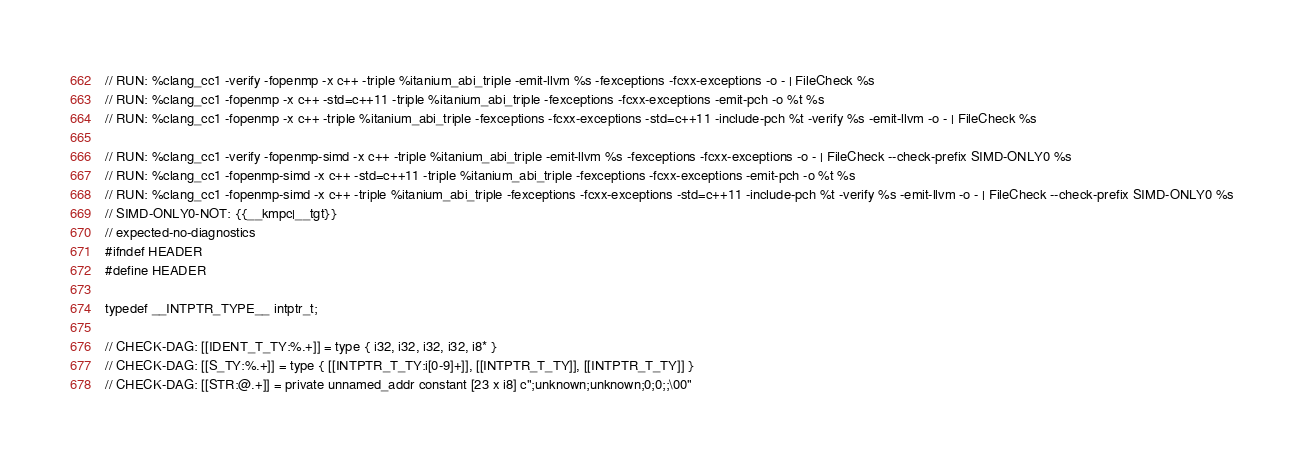Convert code to text. <code><loc_0><loc_0><loc_500><loc_500><_C++_>// RUN: %clang_cc1 -verify -fopenmp -x c++ -triple %itanium_abi_triple -emit-llvm %s -fexceptions -fcxx-exceptions -o - | FileCheck %s
// RUN: %clang_cc1 -fopenmp -x c++ -std=c++11 -triple %itanium_abi_triple -fexceptions -fcxx-exceptions -emit-pch -o %t %s
// RUN: %clang_cc1 -fopenmp -x c++ -triple %itanium_abi_triple -fexceptions -fcxx-exceptions -std=c++11 -include-pch %t -verify %s -emit-llvm -o - | FileCheck %s

// RUN: %clang_cc1 -verify -fopenmp-simd -x c++ -triple %itanium_abi_triple -emit-llvm %s -fexceptions -fcxx-exceptions -o - | FileCheck --check-prefix SIMD-ONLY0 %s
// RUN: %clang_cc1 -fopenmp-simd -x c++ -std=c++11 -triple %itanium_abi_triple -fexceptions -fcxx-exceptions -emit-pch -o %t %s
// RUN: %clang_cc1 -fopenmp-simd -x c++ -triple %itanium_abi_triple -fexceptions -fcxx-exceptions -std=c++11 -include-pch %t -verify %s -emit-llvm -o - | FileCheck --check-prefix SIMD-ONLY0 %s
// SIMD-ONLY0-NOT: {{__kmpc|__tgt}}
// expected-no-diagnostics
#ifndef HEADER
#define HEADER

typedef __INTPTR_TYPE__ intptr_t;

// CHECK-DAG: [[IDENT_T_TY:%.+]] = type { i32, i32, i32, i32, i8* }
// CHECK-DAG: [[S_TY:%.+]] = type { [[INTPTR_T_TY:i[0-9]+]], [[INTPTR_T_TY]], [[INTPTR_T_TY]] }
// CHECK-DAG: [[STR:@.+]] = private unnamed_addr constant [23 x i8] c";unknown;unknown;0;0;;\00"</code> 